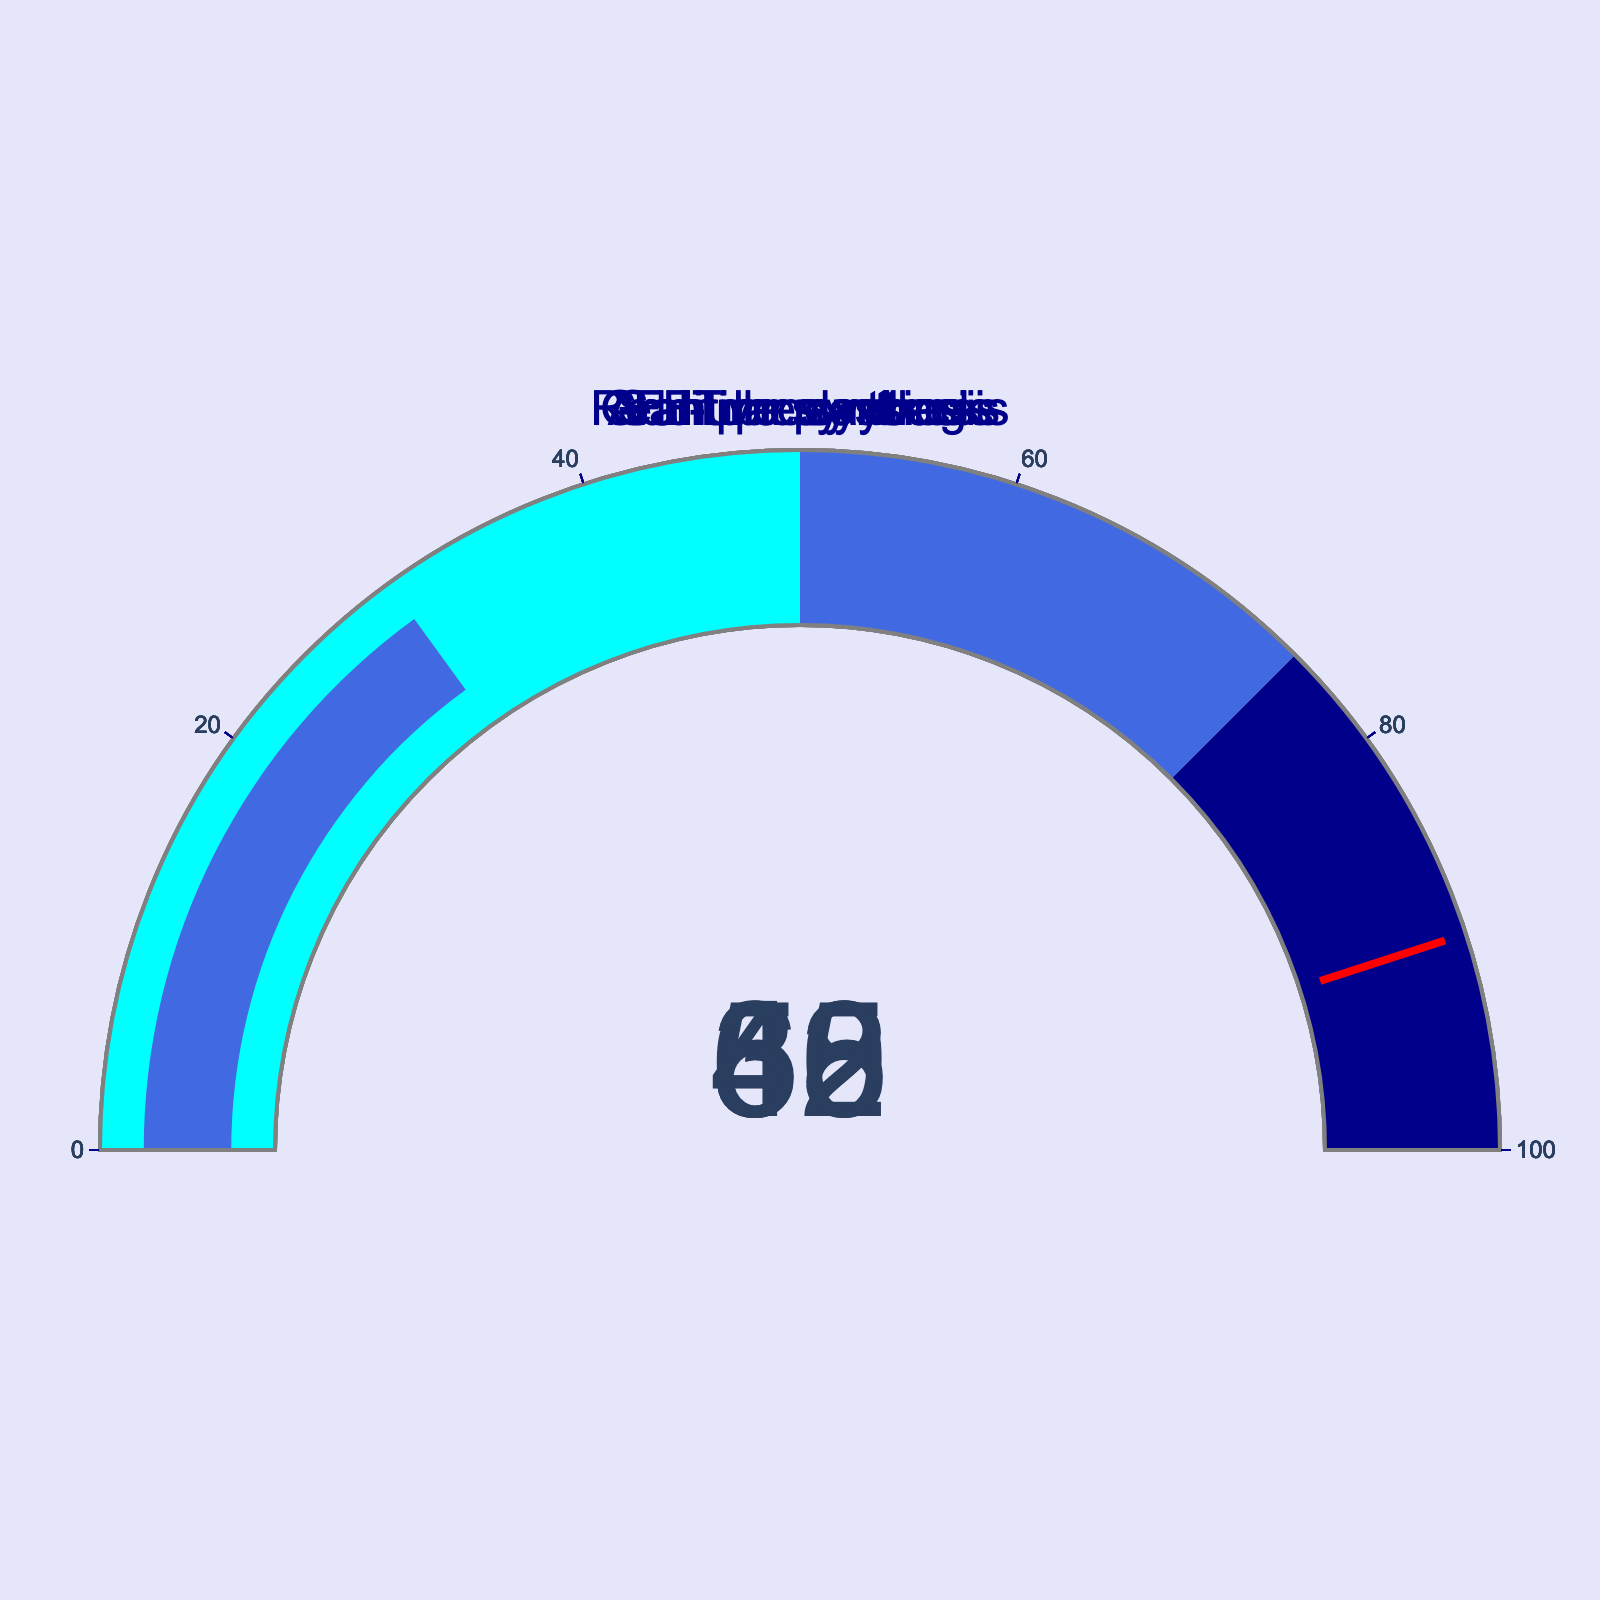what is the utilization percentage for FFT processing? The gauge for FFT processing shows a percentage number indicating its utilization. Reading the figure shows it is 62%.
Answer: 62 how does the utilization for real-time synthesis compare to sample playback? Comparing the gauge values, real-time synthesis utilization is 45% and sample playback is 30%. 45% is higher than 30%.
Answer: real-time synthesis is higher what task has the lowest CPU utilization? By looking at the values for each task, sample playback has the lowest utilization of 30%.
Answer: sample playback what is the difference in CPU utilization between additive synthesis and real-time synthesis? To find the difference, subtract the utilization for real-time synthesis from additive synthesis: 52% - 45% = 7%.
Answer: 7% what is the average CPU utilization across all tasks? Sum the utilizations of all tasks then divide by the number of tasks: (45 + 62 + 38 + 52 + 30) / 5 = 227 / 5 = 45.4%.
Answer: 45.4 which task has the highest CPU utilization, and what is its value? By examining the gauge chart, FFT processing has the highest CPU utilization at 62%.
Answer: FFT processing, 62% compare the CPU utilization of granular synthesis with real-time synthesis. Which has a higher utilization, and by how much? Granular synthesis has 38% utilization and real-time synthesis has 45%. Subtracting the lower from the higher gives a difference of 45% - 38% = 7%. Real-time synthesis is higher.
Answer: real-time synthesis by 7 what is the median CPU utilization value among the tasks? Ordering the utilizations: 30%, 38%, 45%, 52%, 62%. The median is the middle value, which is 45%.
Answer: 45 what proportion of tasks have a CPU utilization above 40%? Out of 5 tasks, 3 (real-time synthesis, additive synthesis, FFT processing) have values above 40%. The proportion is 3/5 or 60%.
Answer: 60% how does the utilization for additive synthesis compare with granular synthesis? Additive synthesis has 52% utilization and granular synthesis has 38%. 52% is higher than 38%.
Answer: additive synthesis is higher 